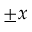<formula> <loc_0><loc_0><loc_500><loc_500>\pm x</formula> 